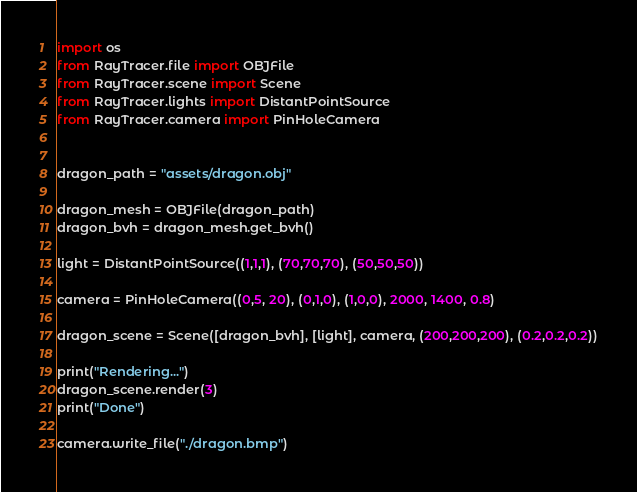Convert code to text. <code><loc_0><loc_0><loc_500><loc_500><_Python_>import os
from RayTracer.file import OBJFile
from RayTracer.scene import Scene
from RayTracer.lights import DistantPointSource
from RayTracer.camera import PinHoleCamera


dragon_path = "assets/dragon.obj"

dragon_mesh = OBJFile(dragon_path)
dragon_bvh = dragon_mesh.get_bvh()

light = DistantPointSource((1,1,1), (70,70,70), (50,50,50))

camera = PinHoleCamera((0,5, 20), (0,1,0), (1,0,0), 2000, 1400, 0.8)

dragon_scene = Scene([dragon_bvh], [light], camera, (200,200,200), (0.2,0.2,0.2))

print("Rendering...")
dragon_scene.render(3)
print("Done")

camera.write_file("./dragon.bmp")
</code> 